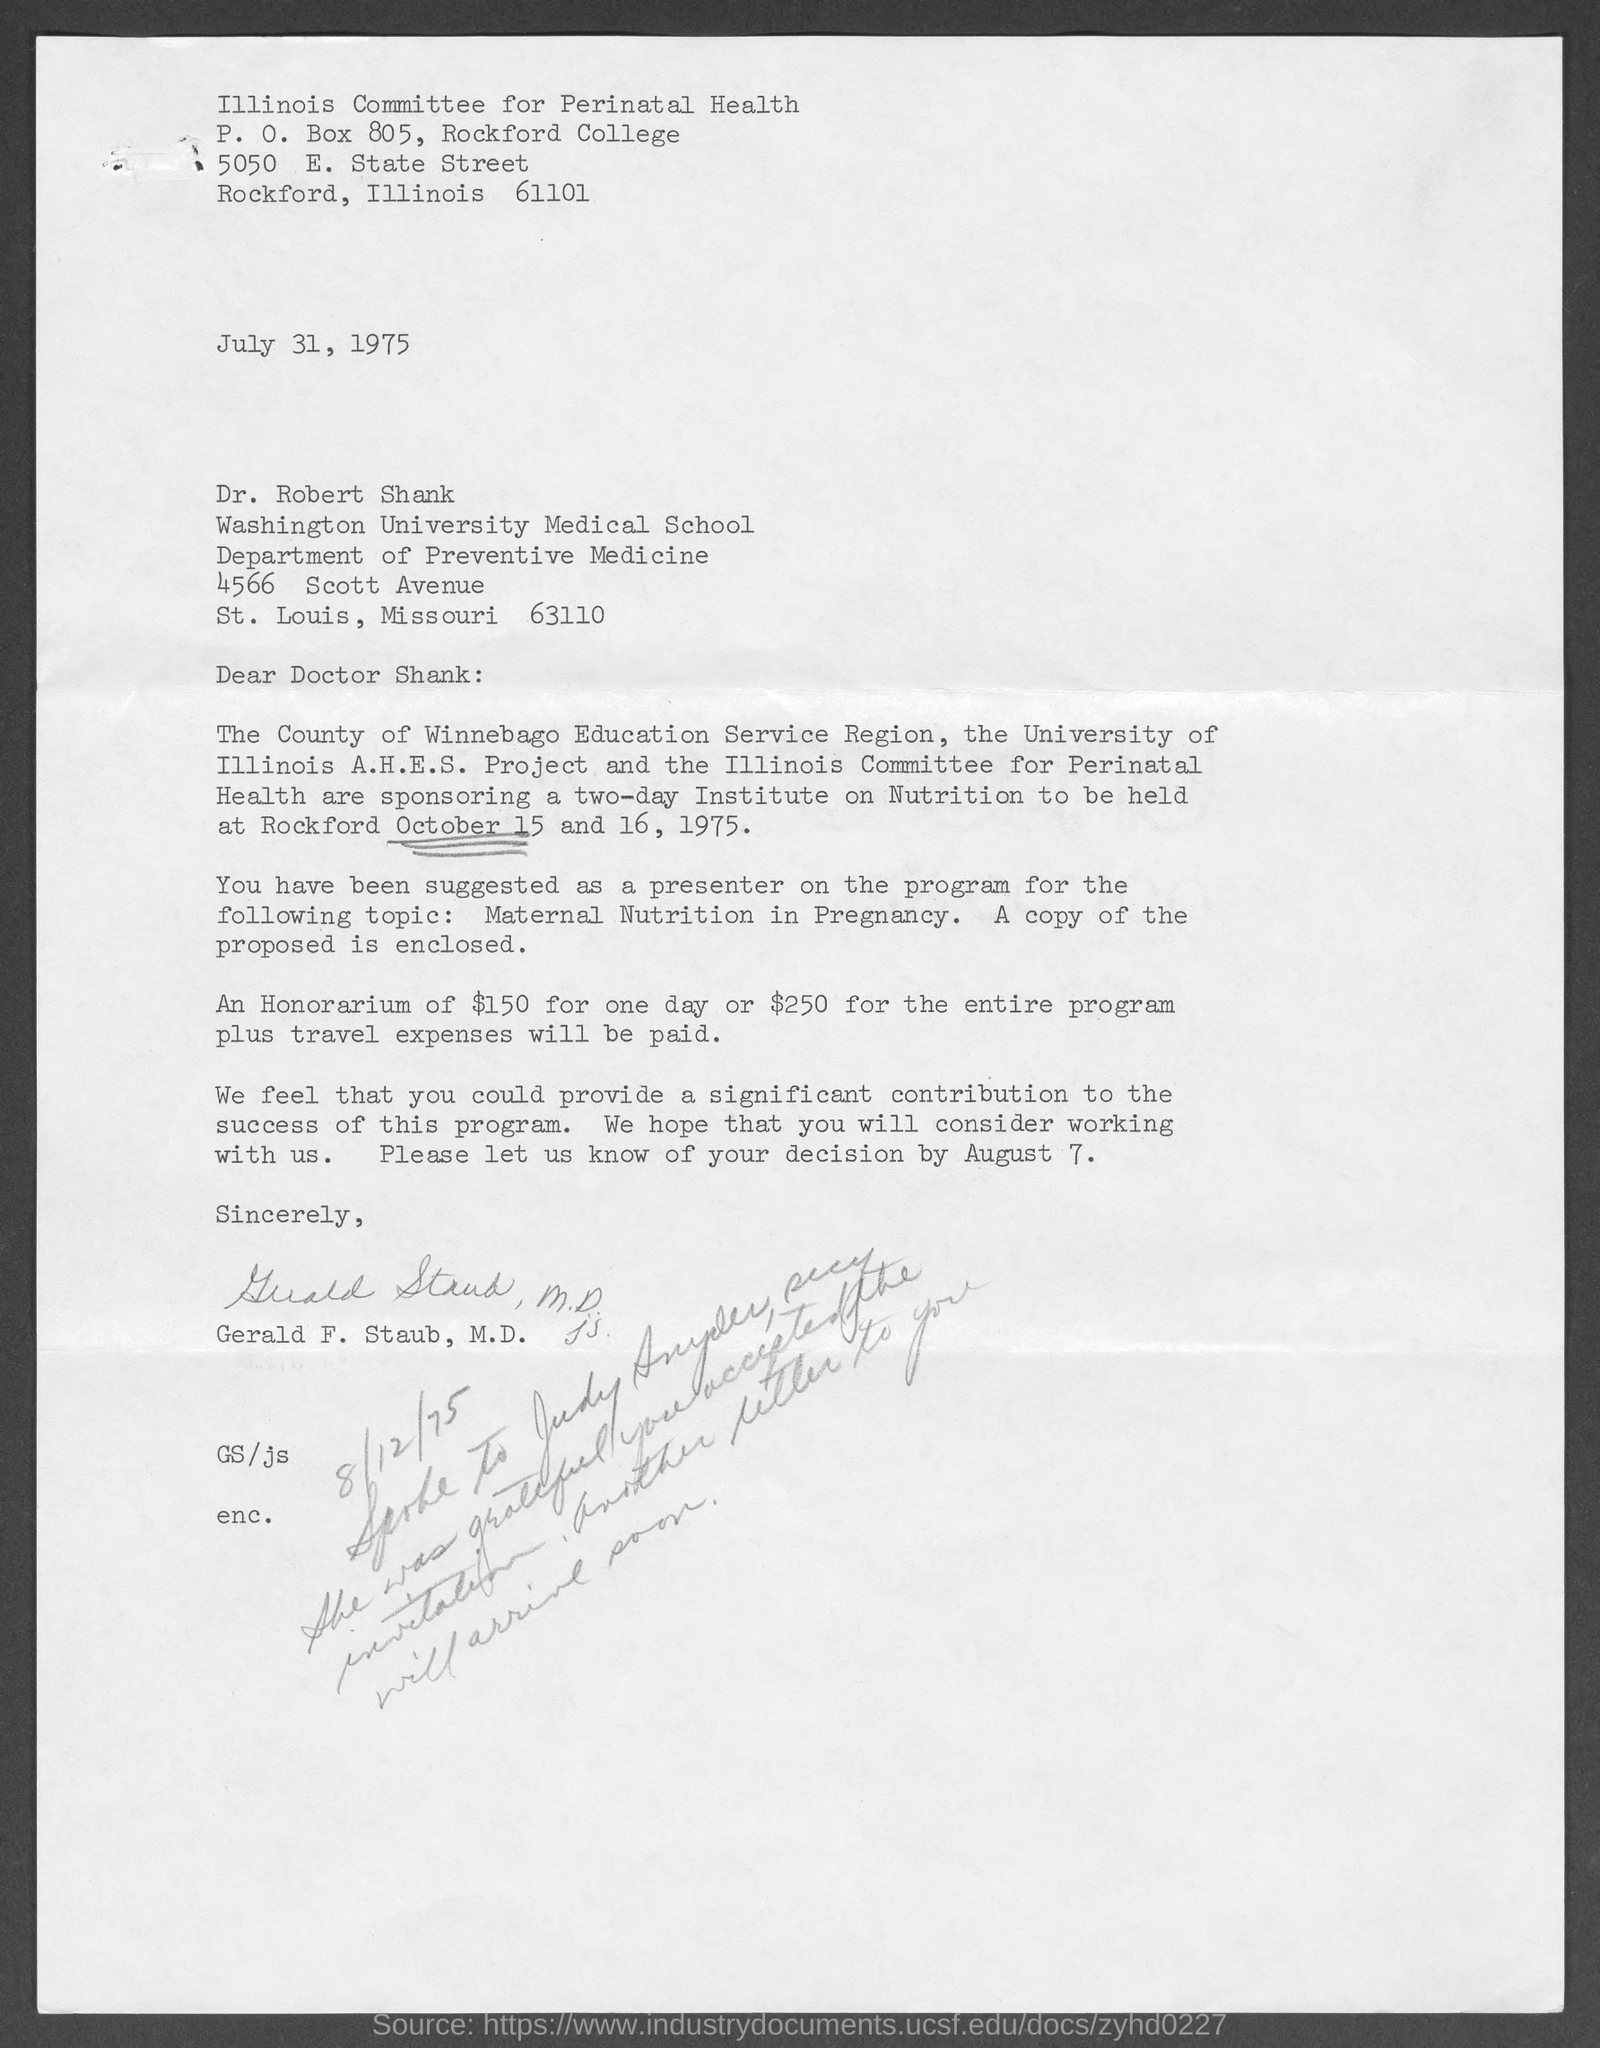What is the issued date of this letter?
Your answer should be compact. July 31, 1975. What is the P. O. Box No mentioned in the letterhead?
Your response must be concise. 805. 